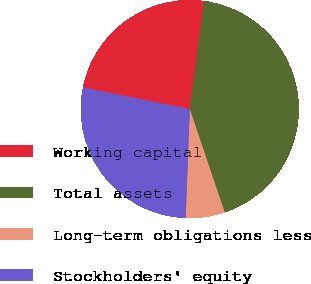Convert chart to OTSL. <chart><loc_0><loc_0><loc_500><loc_500><pie_chart><fcel>Working capital<fcel>Total assets<fcel>Long-term obligations less<fcel>Stockholders' equity<nl><fcel>23.9%<fcel>42.72%<fcel>5.78%<fcel>27.59%<nl></chart> 